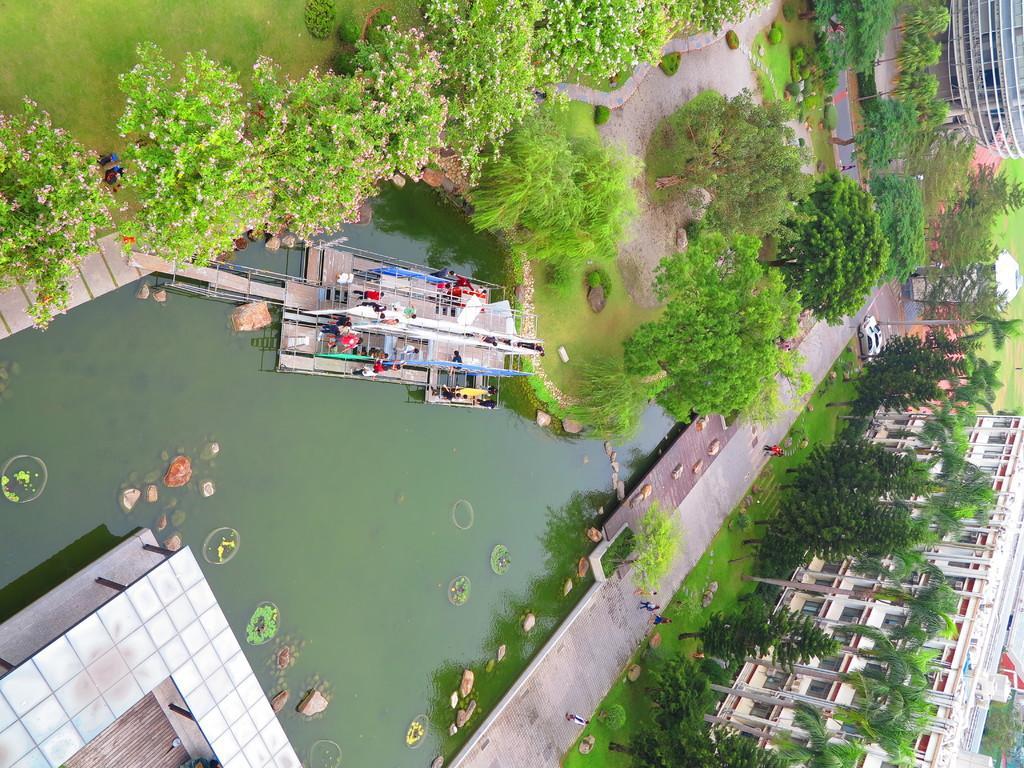How would you summarize this image in a sentence or two? In this image I can see water in the centre and on the both sides of the water I can see grass ground, trees and over the water I can see a platform. I can also see number of people are standing on the platform. On the right side of this image I can see few buildings and few vehicles. I can also see few more people on the right side. 